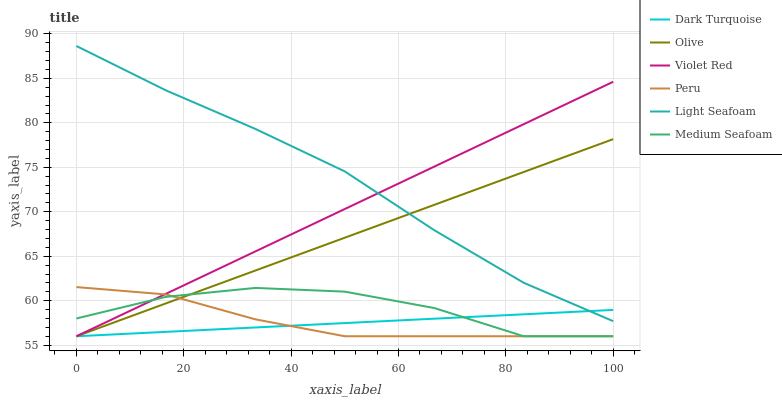Does Dark Turquoise have the minimum area under the curve?
Answer yes or no. Yes. Does Light Seafoam have the maximum area under the curve?
Answer yes or no. Yes. Does Peru have the minimum area under the curve?
Answer yes or no. No. Does Peru have the maximum area under the curve?
Answer yes or no. No. Is Dark Turquoise the smoothest?
Answer yes or no. Yes. Is Medium Seafoam the roughest?
Answer yes or no. Yes. Is Peru the smoothest?
Answer yes or no. No. Is Peru the roughest?
Answer yes or no. No. Does Violet Red have the lowest value?
Answer yes or no. Yes. Does Light Seafoam have the lowest value?
Answer yes or no. No. Does Light Seafoam have the highest value?
Answer yes or no. Yes. Does Peru have the highest value?
Answer yes or no. No. Is Medium Seafoam less than Light Seafoam?
Answer yes or no. Yes. Is Light Seafoam greater than Peru?
Answer yes or no. Yes. Does Peru intersect Dark Turquoise?
Answer yes or no. Yes. Is Peru less than Dark Turquoise?
Answer yes or no. No. Is Peru greater than Dark Turquoise?
Answer yes or no. No. Does Medium Seafoam intersect Light Seafoam?
Answer yes or no. No. 